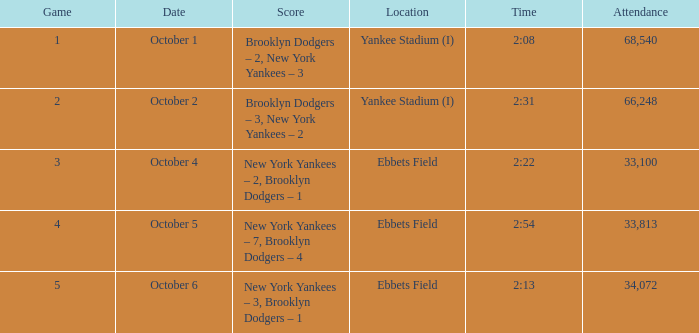What was the Attendance when the Time was 2:13? 34072.0. 